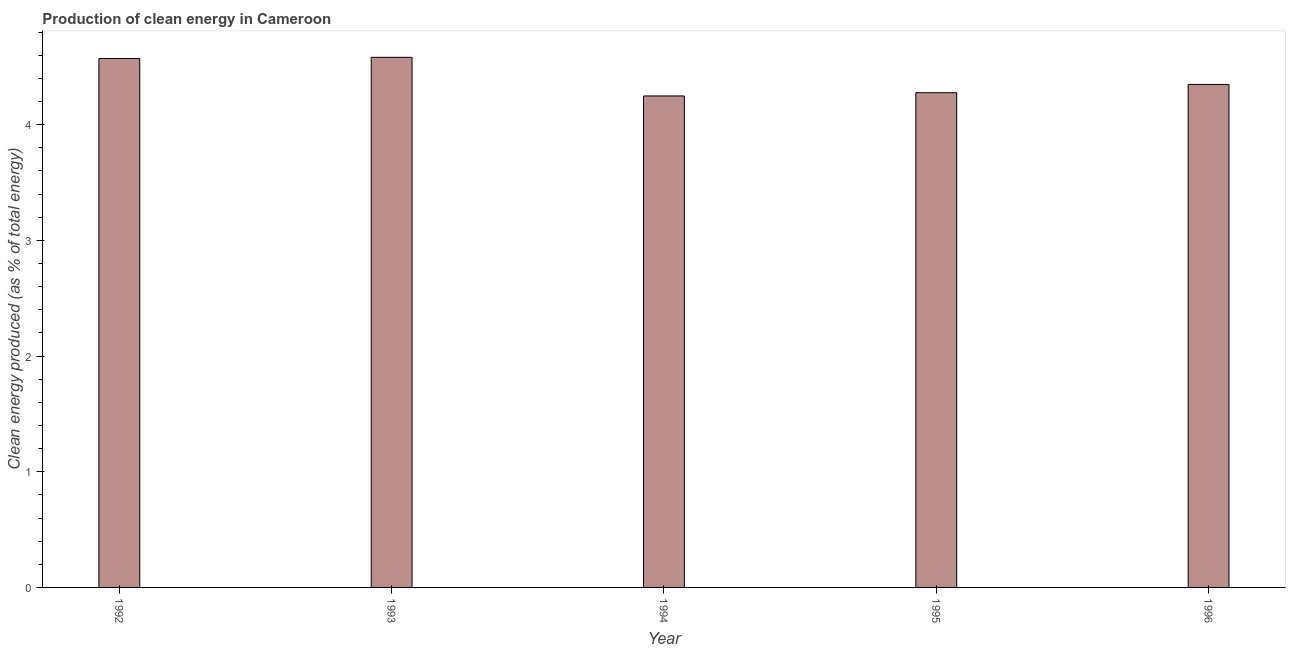Does the graph contain any zero values?
Make the answer very short. No. Does the graph contain grids?
Offer a terse response. No. What is the title of the graph?
Your response must be concise. Production of clean energy in Cameroon. What is the label or title of the X-axis?
Offer a terse response. Year. What is the label or title of the Y-axis?
Your answer should be very brief. Clean energy produced (as % of total energy). What is the production of clean energy in 1995?
Give a very brief answer. 4.28. Across all years, what is the maximum production of clean energy?
Provide a succinct answer. 4.58. Across all years, what is the minimum production of clean energy?
Provide a succinct answer. 4.25. In which year was the production of clean energy maximum?
Ensure brevity in your answer.  1993. What is the sum of the production of clean energy?
Your response must be concise. 22.02. What is the difference between the production of clean energy in 1994 and 1996?
Your answer should be very brief. -0.1. What is the average production of clean energy per year?
Offer a very short reply. 4.4. What is the median production of clean energy?
Your answer should be very brief. 4.35. Do a majority of the years between 1995 and 1994 (inclusive) have production of clean energy greater than 3.4 %?
Ensure brevity in your answer.  No. What is the ratio of the production of clean energy in 1994 to that in 1996?
Your answer should be very brief. 0.98. Is the difference between the production of clean energy in 1992 and 1993 greater than the difference between any two years?
Offer a very short reply. No. What is the difference between the highest and the second highest production of clean energy?
Make the answer very short. 0.01. Is the sum of the production of clean energy in 1993 and 1996 greater than the maximum production of clean energy across all years?
Provide a short and direct response. Yes. What is the difference between the highest and the lowest production of clean energy?
Offer a terse response. 0.33. What is the Clean energy produced (as % of total energy) of 1992?
Offer a terse response. 4.57. What is the Clean energy produced (as % of total energy) of 1993?
Provide a short and direct response. 4.58. What is the Clean energy produced (as % of total energy) in 1994?
Offer a very short reply. 4.25. What is the Clean energy produced (as % of total energy) in 1995?
Your answer should be compact. 4.28. What is the Clean energy produced (as % of total energy) in 1996?
Your response must be concise. 4.35. What is the difference between the Clean energy produced (as % of total energy) in 1992 and 1993?
Provide a succinct answer. -0.01. What is the difference between the Clean energy produced (as % of total energy) in 1992 and 1994?
Offer a very short reply. 0.32. What is the difference between the Clean energy produced (as % of total energy) in 1992 and 1995?
Provide a succinct answer. 0.3. What is the difference between the Clean energy produced (as % of total energy) in 1992 and 1996?
Your answer should be very brief. 0.22. What is the difference between the Clean energy produced (as % of total energy) in 1993 and 1994?
Ensure brevity in your answer.  0.33. What is the difference between the Clean energy produced (as % of total energy) in 1993 and 1995?
Make the answer very short. 0.31. What is the difference between the Clean energy produced (as % of total energy) in 1993 and 1996?
Provide a short and direct response. 0.23. What is the difference between the Clean energy produced (as % of total energy) in 1994 and 1995?
Your answer should be compact. -0.03. What is the difference between the Clean energy produced (as % of total energy) in 1994 and 1996?
Your response must be concise. -0.1. What is the difference between the Clean energy produced (as % of total energy) in 1995 and 1996?
Provide a short and direct response. -0.07. What is the ratio of the Clean energy produced (as % of total energy) in 1992 to that in 1994?
Your answer should be very brief. 1.08. What is the ratio of the Clean energy produced (as % of total energy) in 1992 to that in 1995?
Offer a terse response. 1.07. What is the ratio of the Clean energy produced (as % of total energy) in 1992 to that in 1996?
Provide a short and direct response. 1.05. What is the ratio of the Clean energy produced (as % of total energy) in 1993 to that in 1994?
Ensure brevity in your answer.  1.08. What is the ratio of the Clean energy produced (as % of total energy) in 1993 to that in 1995?
Make the answer very short. 1.07. What is the ratio of the Clean energy produced (as % of total energy) in 1993 to that in 1996?
Provide a short and direct response. 1.05. What is the ratio of the Clean energy produced (as % of total energy) in 1994 to that in 1995?
Provide a succinct answer. 0.99. 